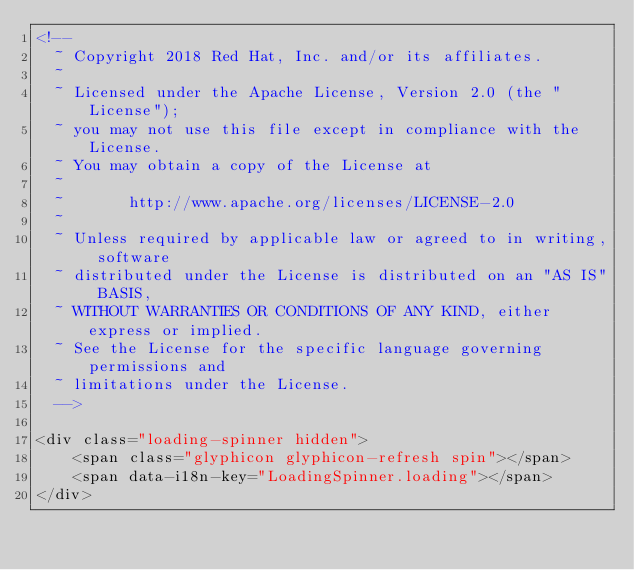<code> <loc_0><loc_0><loc_500><loc_500><_HTML_><!--
  ~ Copyright 2018 Red Hat, Inc. and/or its affiliates.
  ~
  ~ Licensed under the Apache License, Version 2.0 (the "License");
  ~ you may not use this file except in compliance with the License.
  ~ You may obtain a copy of the License at
  ~
  ~       http://www.apache.org/licenses/LICENSE-2.0
  ~
  ~ Unless required by applicable law or agreed to in writing, software
  ~ distributed under the License is distributed on an "AS IS" BASIS,
  ~ WITHOUT WARRANTIES OR CONDITIONS OF ANY KIND, either express or implied.
  ~ See the License for the specific language governing permissions and
  ~ limitations under the License.
  -->

<div class="loading-spinner hidden">
    <span class="glyphicon glyphicon-refresh spin"></span>
    <span data-i18n-key="LoadingSpinner.loading"></span>
</div></code> 